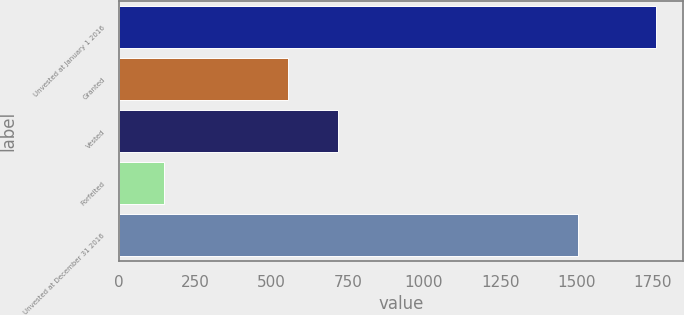Convert chart. <chart><loc_0><loc_0><loc_500><loc_500><bar_chart><fcel>Unvested at January 1 2016<fcel>Granted<fcel>Vested<fcel>Forfeited<fcel>Unvested at December 31 2016<nl><fcel>1762<fcel>555<fcel>716.4<fcel>148<fcel>1505<nl></chart> 